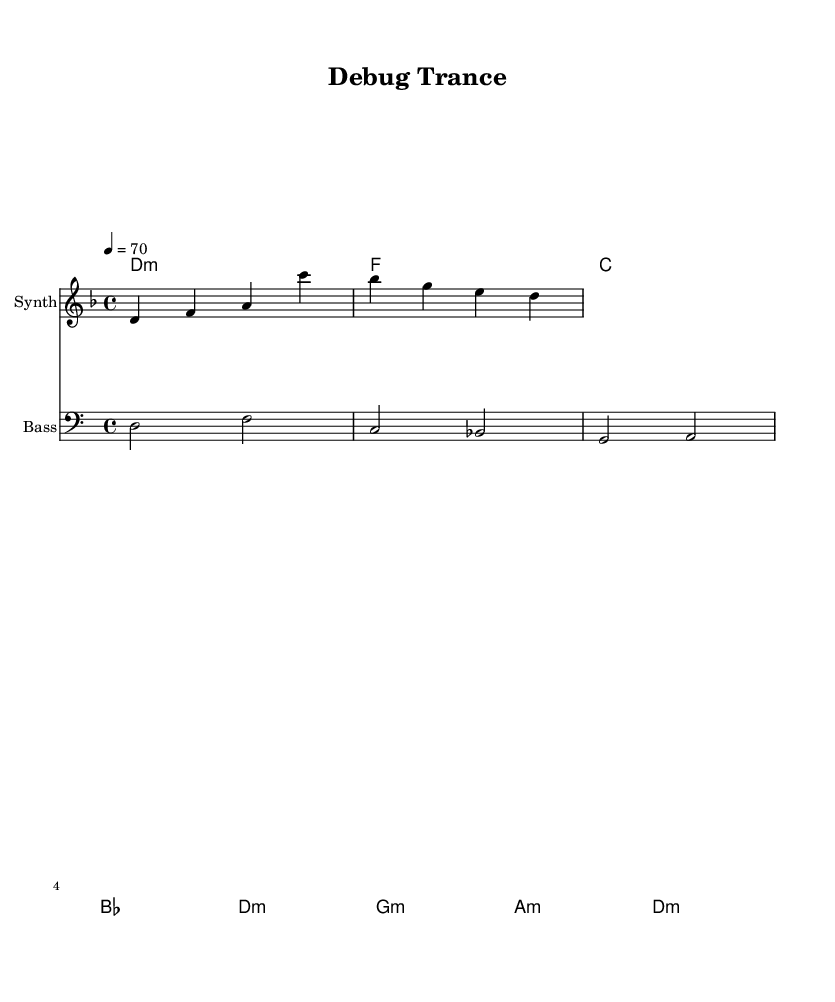What is the key signature of this music? The key signature is indicated by the presence of a B flat in the staff, which means it is in D minor, as it has one flat.
Answer: D minor What is the time signature of this music? The time signature is shown at the beginning of the staff, where there is a “4/4” indicating the music is in common time with four beats per measure.
Answer: 4/4 What is the tempo marking for this piece? The tempo marking is shown as "4 = 70," meaning each quarter note is to be played at 70 beats per minute.
Answer: 70 How many measures are in the melody section? By counting the distinct groupings of notes and bars within the melody part, we see there are a total of 4 measures represented.
Answer: 4 What type of chords are primarily used in the harmonies? The chord symbols show that this piece primarily utilizes minor chords, indicated by the “m” after the chord letter, which points to a darker sound signature typical in ambient music.
Answer: Minor What is the clef used for the bass section? The bass section explicitly notes that it is using a bass clef, which is a notation used for lower-pitched instruments.
Answer: Bass What mood or atmosphere does the piece aim to create? Given the minor key signature, slow tempo, and chord selection, the piece creates a contemplative, immersive atmosphere suited for concentration, typically found in ambient music.
Answer: Contemplative 